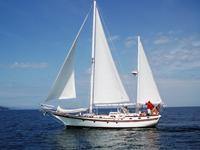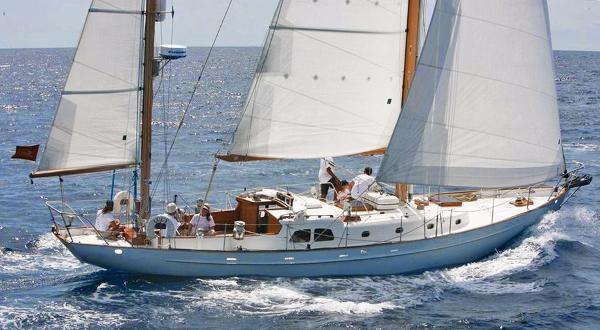The first image is the image on the left, the second image is the image on the right. For the images displayed, is the sentence "The boat in the image on the left has no sails up." factually correct? Answer yes or no. No. The first image is the image on the left, the second image is the image on the right. Evaluate the accuracy of this statement regarding the images: "The boat in the left image has furled sails, while the boat on the right is moving and creating white spray.". Is it true? Answer yes or no. No. 